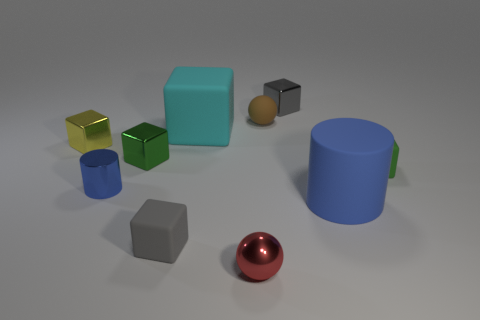Do the metallic cylinder and the cylinder that is on the right side of the tiny red shiny object have the same color?
Ensure brevity in your answer.  Yes. What shape is the small shiny thing that is the same color as the matte cylinder?
Keep it short and to the point. Cylinder. Is the large cube made of the same material as the yellow object?
Your answer should be very brief. No. There is a small green thing on the right side of the rubber cylinder behind the small metallic object in front of the blue metallic thing; what shape is it?
Keep it short and to the point. Cube. Are there fewer rubber cylinders to the left of the yellow shiny thing than large objects on the left side of the blue rubber cylinder?
Offer a very short reply. Yes. What is the shape of the yellow object on the left side of the sphere that is in front of the small gray matte thing?
Your answer should be very brief. Cube. Is there anything else that has the same color as the big block?
Offer a terse response. No. Is the matte ball the same color as the metal ball?
Your answer should be very brief. No. How many green things are small blocks or metal balls?
Ensure brevity in your answer.  2. Is the number of gray matte cubes behind the green rubber block less than the number of blue rubber cylinders?
Provide a succinct answer. Yes. 